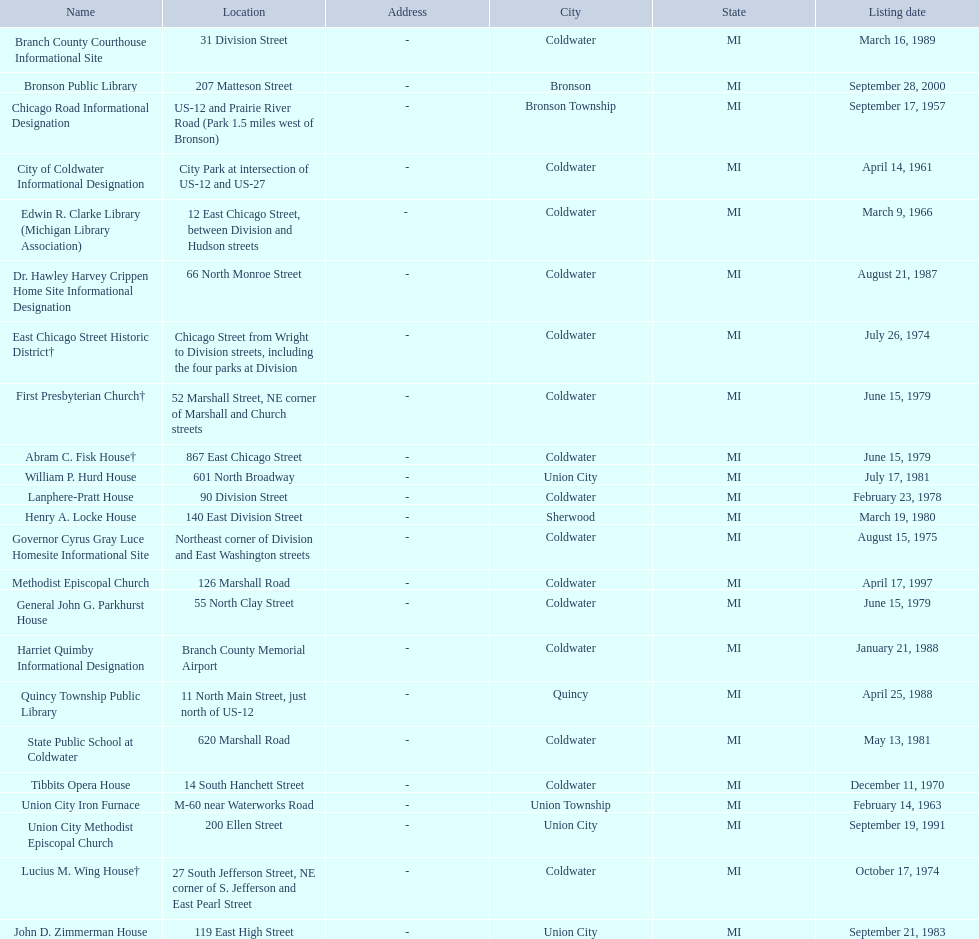Which city has the largest number of historic sites? Coldwater. 